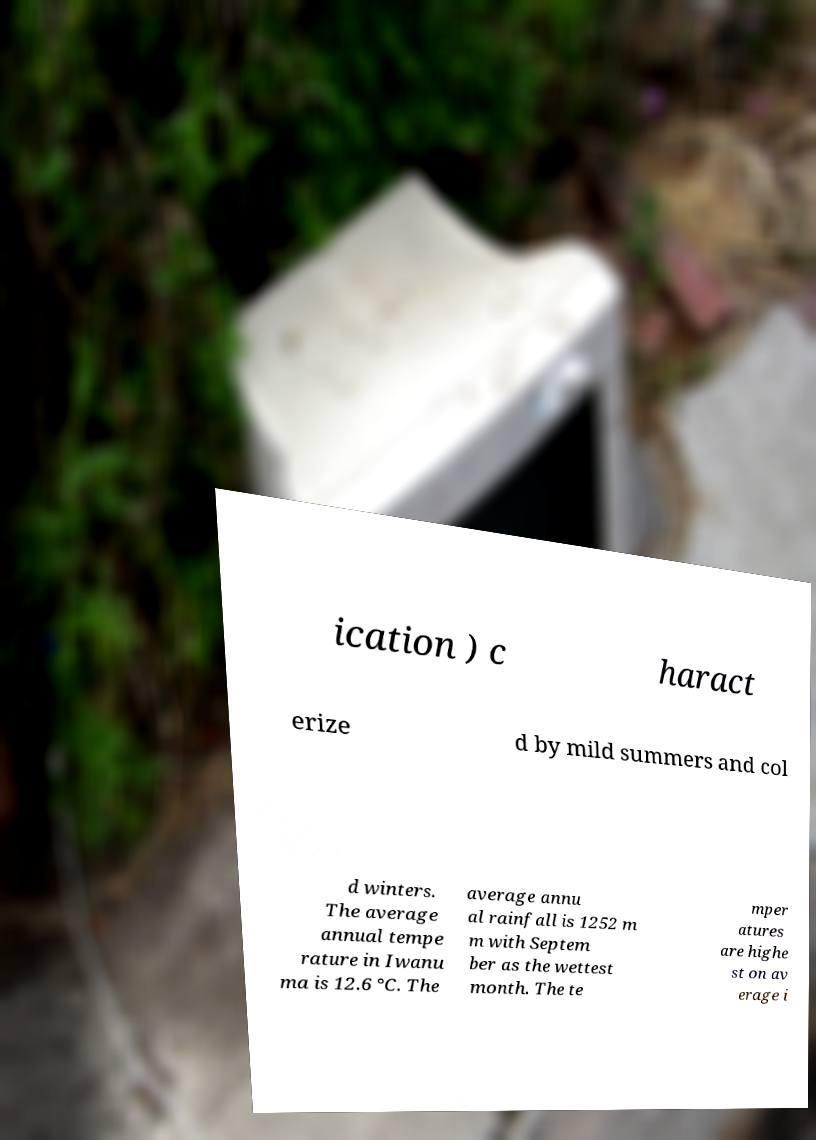Can you read and provide the text displayed in the image?This photo seems to have some interesting text. Can you extract and type it out for me? ication ) c haract erize d by mild summers and col d winters. The average annual tempe rature in Iwanu ma is 12.6 °C. The average annu al rainfall is 1252 m m with Septem ber as the wettest month. The te mper atures are highe st on av erage i 